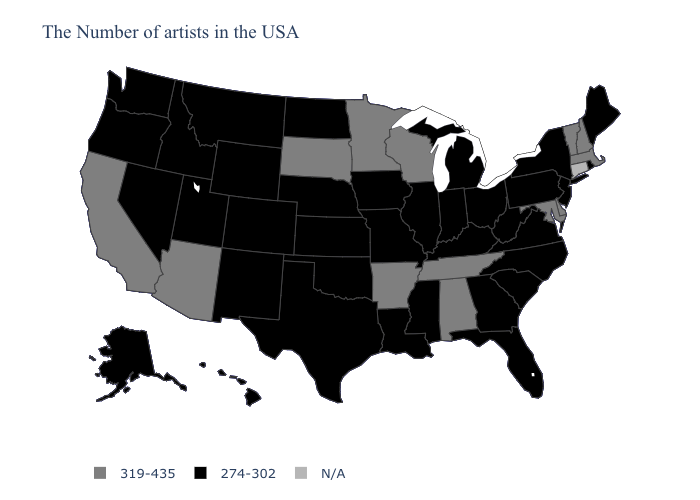Which states hav the highest value in the MidWest?
Write a very short answer. Wisconsin, Minnesota, South Dakota. Which states hav the highest value in the South?
Keep it brief. Delaware, Maryland, Alabama, Tennessee, Arkansas. Does Alabama have the lowest value in the USA?
Answer briefly. No. What is the value of Arizona?
Keep it brief. 319-435. Does the map have missing data?
Concise answer only. Yes. What is the highest value in states that border Louisiana?
Short answer required. 319-435. Does the first symbol in the legend represent the smallest category?
Answer briefly. No. Name the states that have a value in the range N/A?
Short answer required. Connecticut. What is the value of Maryland?
Write a very short answer. 319-435. What is the value of Connecticut?
Write a very short answer. N/A. Does Tennessee have the lowest value in the South?
Concise answer only. No. What is the value of Alaska?
Be succinct. 274-302. What is the lowest value in the MidWest?
Answer briefly. 274-302. 